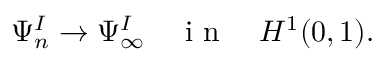Convert formula to latex. <formula><loc_0><loc_0><loc_500><loc_500>\begin{array} { r } { \Psi _ { n } ^ { I } \to \Psi _ { \infty } ^ { I } \quad i n \quad H ^ { 1 } ( 0 , 1 ) . } \end{array}</formula> 